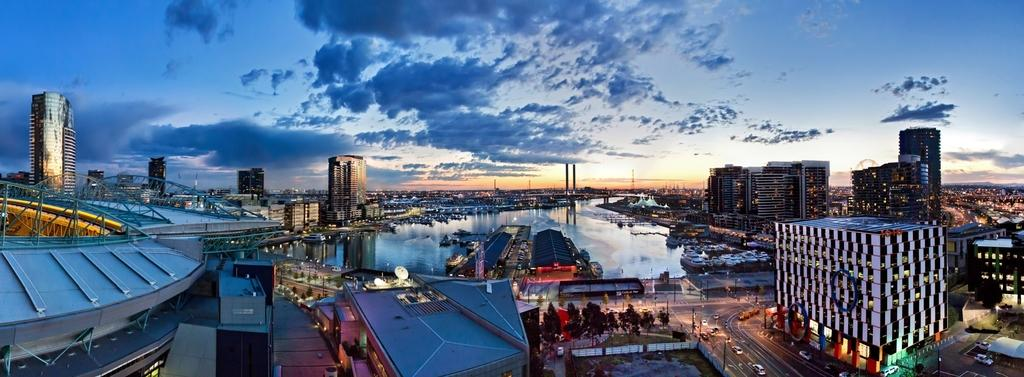What type of structures can be seen in the image? There are many buildings in the image. What other natural elements are present in the image? There are trees in the image. What mode of transportation can be seen on the road in the image? There are vehicles on the road in the image. What object is visible in the image that might be used for signage or support? There is a pole visible in the image. What body of water can be seen in the image? There is water visible in the image. What type of letters are being served with rice in the image? There is no mention of letters or rice in the image; it features buildings, trees, vehicles, a pole, and water. 